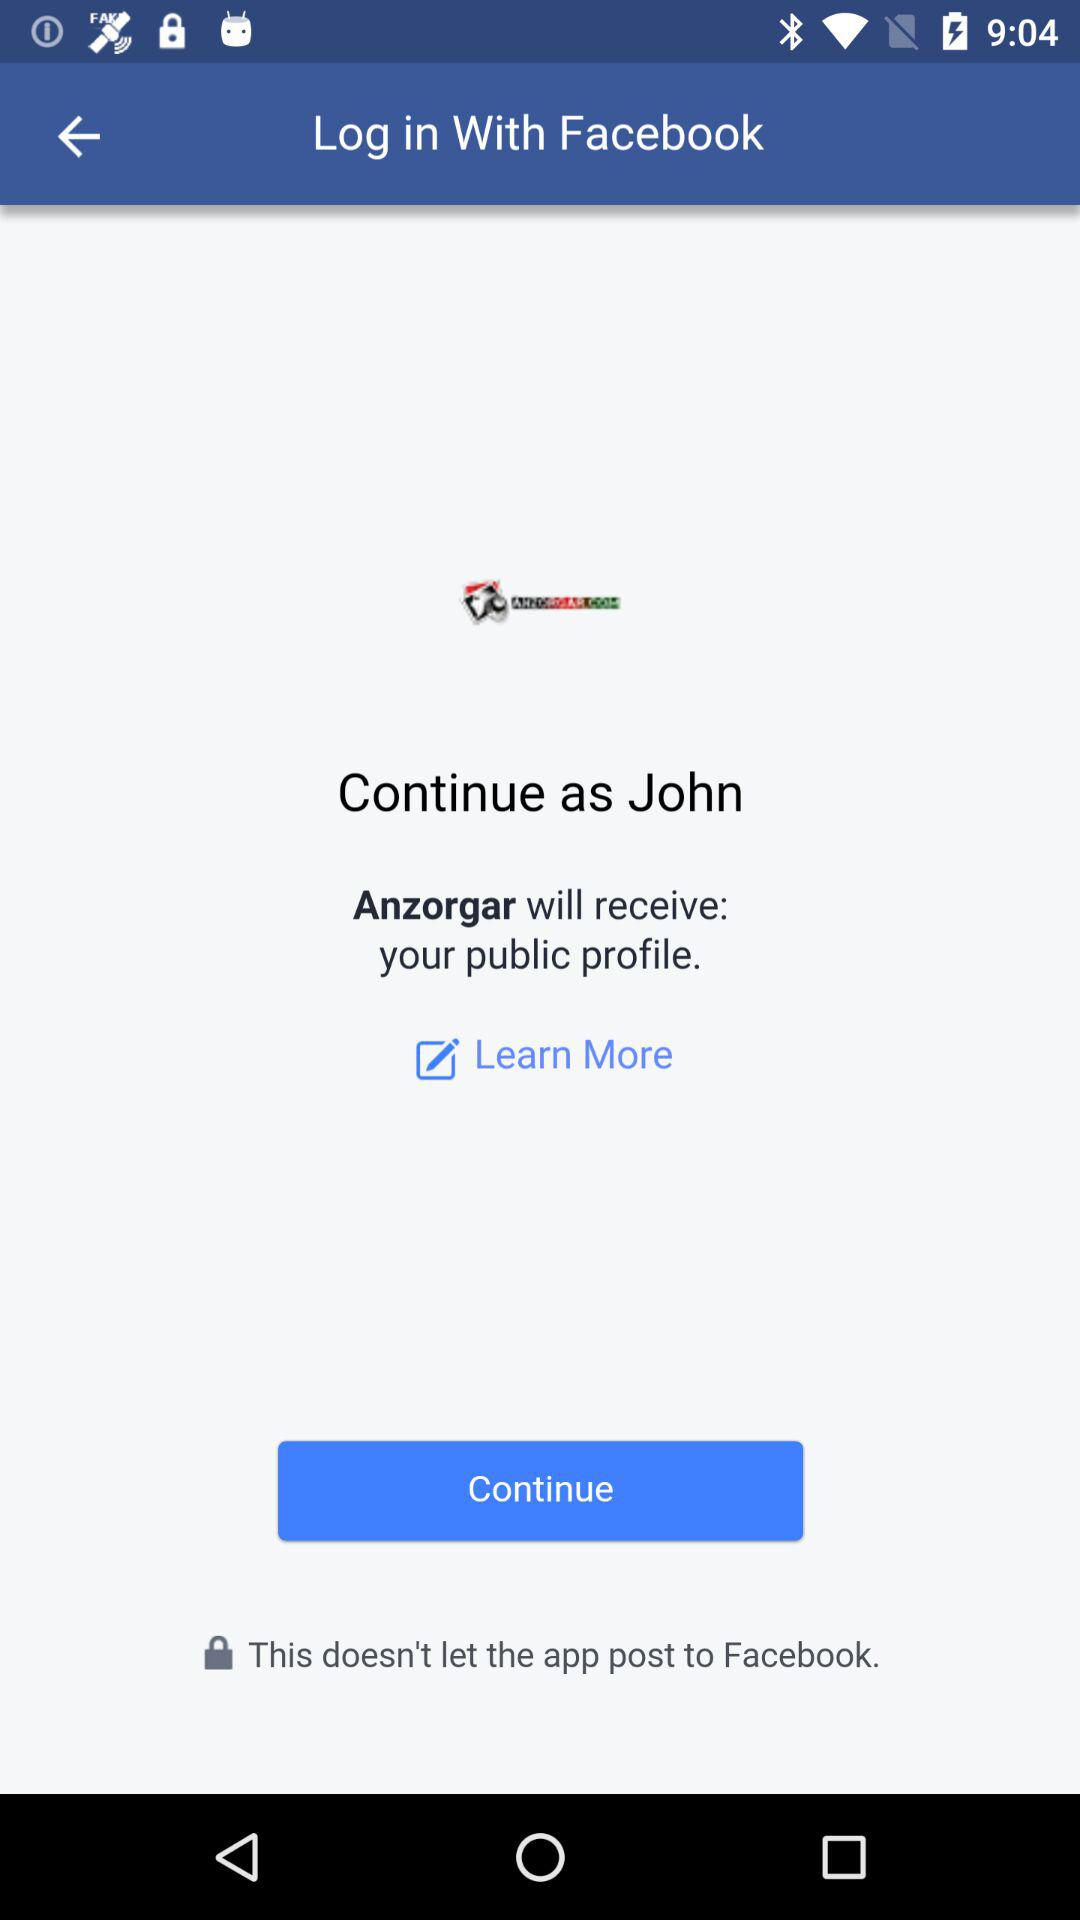What is the name of the user? The name of the user is John. 